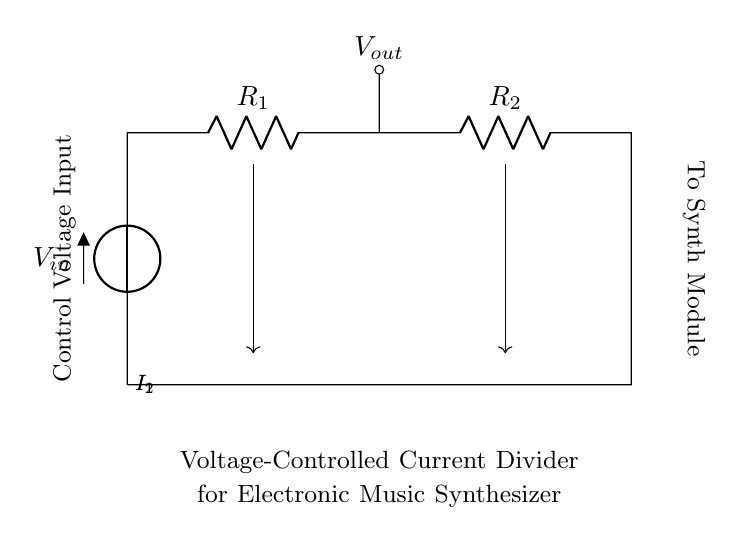What is the input voltage in the circuit? The circuit shows a voltage source labeled V-in connected to the upper part of the circuit.
Answer: V-in What are the components used in this circuit? The circuit consists of two resistors (R1 and R2) and a voltage source (V-in).
Answer: Resistors and a voltage source What is the control voltage input used for? The control voltage input is indicated at the left side of the circuit as the variable influencing the divider operation.
Answer: Divider operation How do the currents I1 and I2 relate to R1 and R2? According to current divider rules, I1 and I2 depend on the resistance values of R1 and R2, where I1 is inversely proportional to R1 and I2 to R2.
Answer: Inversely proportional What happens to the output voltage when the control voltage increases? Increasing the control voltage typically leads to a change in current distribution across R1 and R2, affecting the output voltage.
Answer: Changes output voltage What would be the effect of shorting R2 in this circuit? Shorting R2 would bypass it, leading to all of the input current flowing through R1, altering current distribution and potentially increasing output voltage.
Answer: Bypass R2 What type of circuit is this? This circuit operates as a voltage-controlled current divider, allowing for manipulation of current based on an external control voltage.
Answer: Voltage-controlled current divider 